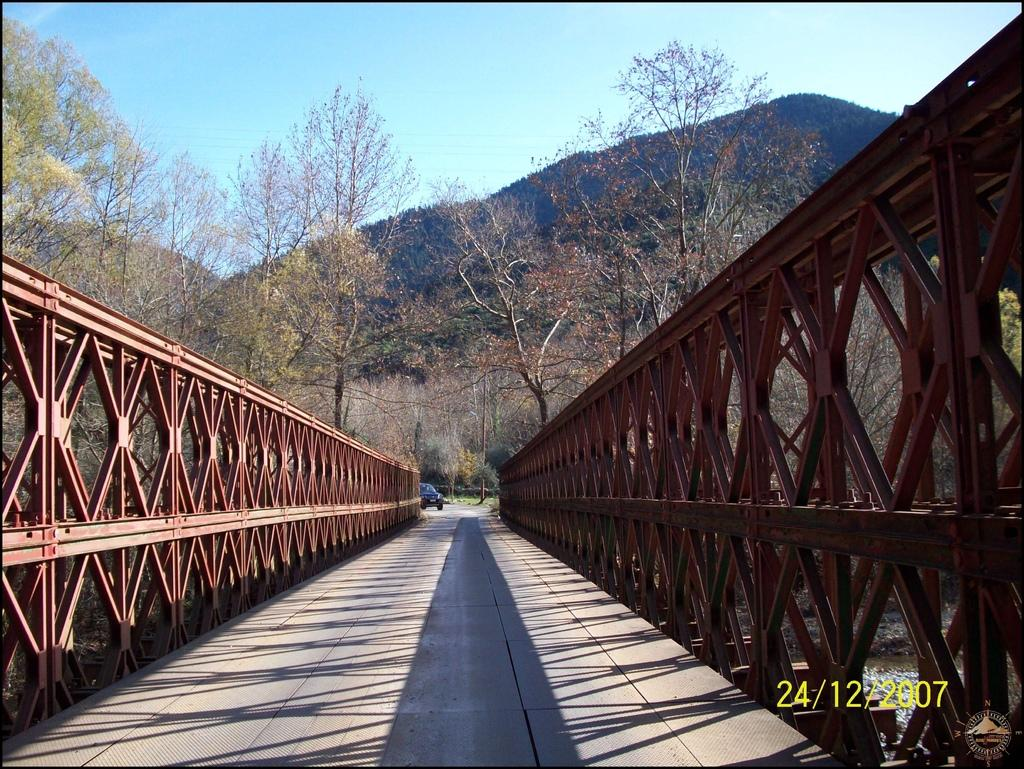What structure is present in the image? There is a bridge in the image. What else can be seen on the ground in the image? There is a vehicle on the ground in the image. What type of natural scenery is visible in the background of the image? There are trees and a mountain in the background of the image. What part of the natural environment is visible in the image? The sky is visible in the background of the image. How does the vehicle experience a loss in the image? There is no indication of loss experienced by the vehicle in the image. What type of iron is used to construct the bridge in the image? The image does not provide information about the materials used to construct the bridge. 